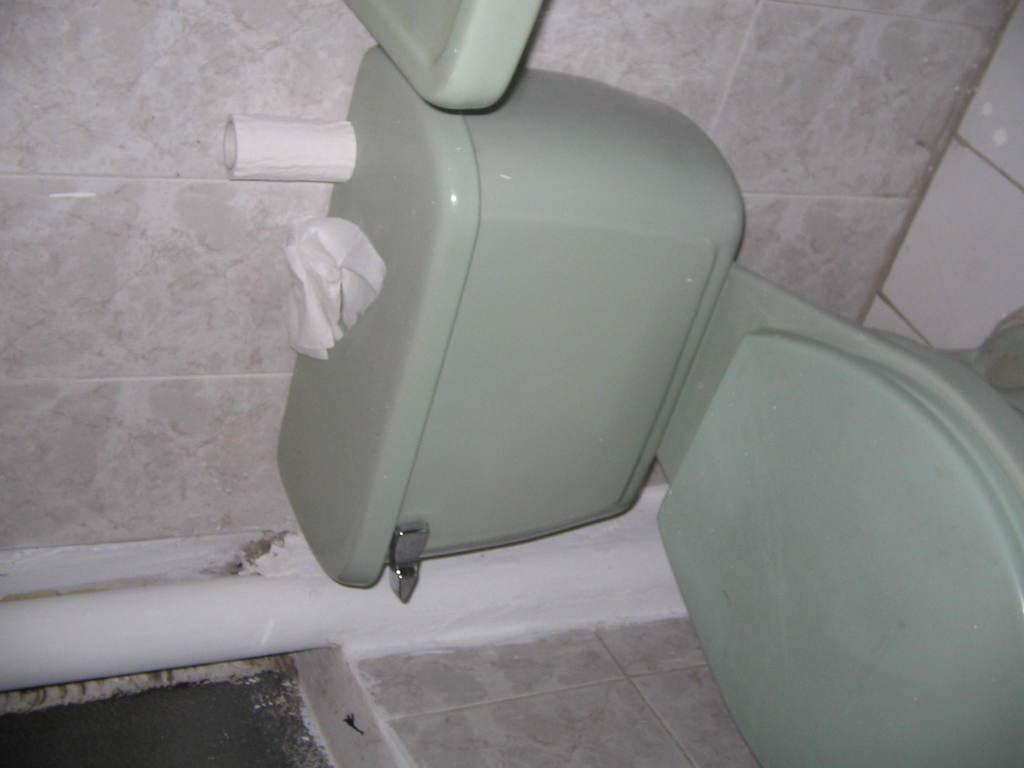What is the main object in the image? There is a toilet in the image. What is placed on the toilet? There is a tissue roll and tissue paper on the toilet. What can be seen at the bottom of the image? There is a pipe at the bottom of the image. What type of flooring is visible in the image? The image contains tiles. What type of wool can be seen in the image? There is no wool present in the image. What nation is depicted in the image? The image does not depict any nation; it is a close-up view of a toilet with tissue roll and tissue paper. 